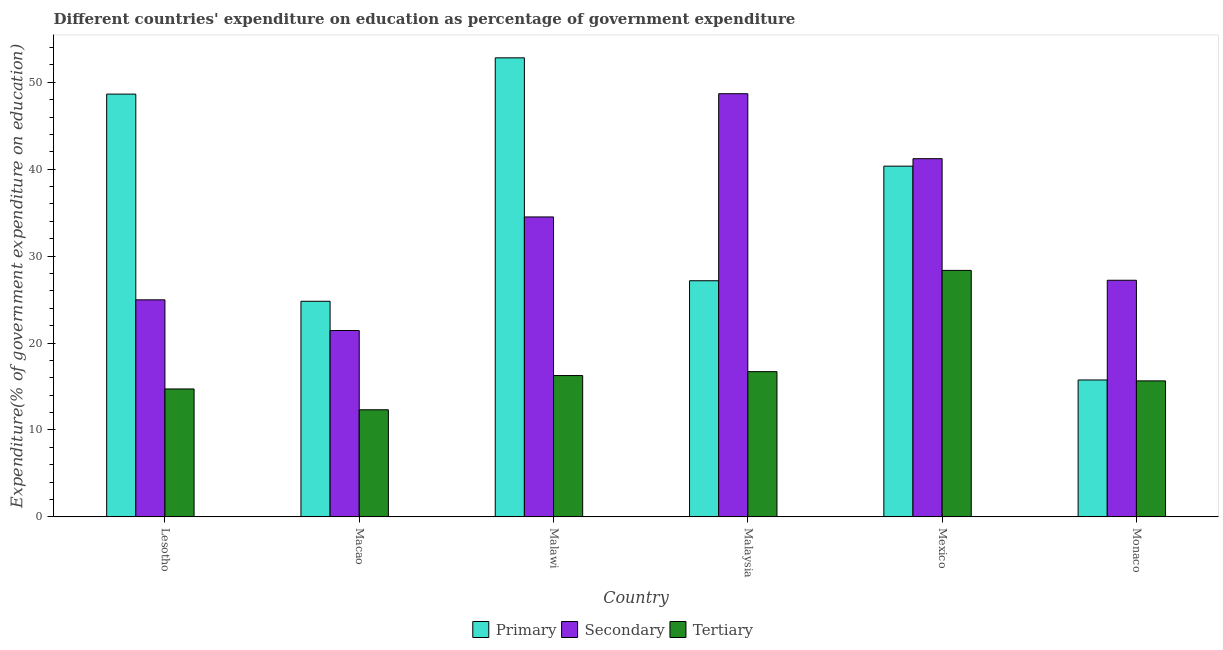How many bars are there on the 1st tick from the left?
Offer a terse response. 3. What is the label of the 5th group of bars from the left?
Provide a short and direct response. Mexico. What is the expenditure on primary education in Monaco?
Make the answer very short. 15.75. Across all countries, what is the maximum expenditure on primary education?
Your answer should be very brief. 52.81. Across all countries, what is the minimum expenditure on secondary education?
Offer a terse response. 21.44. In which country was the expenditure on primary education maximum?
Offer a terse response. Malawi. In which country was the expenditure on secondary education minimum?
Your answer should be very brief. Macao. What is the total expenditure on secondary education in the graph?
Offer a terse response. 198.04. What is the difference between the expenditure on secondary education in Malawi and that in Malaysia?
Your answer should be compact. -14.17. What is the difference between the expenditure on tertiary education in Macao and the expenditure on primary education in Mexico?
Keep it short and to the point. -28.03. What is the average expenditure on secondary education per country?
Offer a terse response. 33.01. What is the difference between the expenditure on primary education and expenditure on tertiary education in Macao?
Your answer should be compact. 12.48. In how many countries, is the expenditure on secondary education greater than 36 %?
Give a very brief answer. 2. What is the ratio of the expenditure on secondary education in Lesotho to that in Malawi?
Give a very brief answer. 0.72. What is the difference between the highest and the second highest expenditure on primary education?
Provide a short and direct response. 4.17. What is the difference between the highest and the lowest expenditure on primary education?
Provide a short and direct response. 37.06. What does the 2nd bar from the left in Lesotho represents?
Your answer should be very brief. Secondary. What does the 1st bar from the right in Mexico represents?
Your answer should be compact. Tertiary. Are all the bars in the graph horizontal?
Keep it short and to the point. No. How many countries are there in the graph?
Provide a short and direct response. 6. Does the graph contain grids?
Offer a terse response. No. How many legend labels are there?
Your answer should be very brief. 3. What is the title of the graph?
Provide a short and direct response. Different countries' expenditure on education as percentage of government expenditure. Does "Wage workers" appear as one of the legend labels in the graph?
Keep it short and to the point. No. What is the label or title of the Y-axis?
Your response must be concise. Expenditure(% of government expenditure on education). What is the Expenditure(% of government expenditure on education) of Primary in Lesotho?
Make the answer very short. 48.64. What is the Expenditure(% of government expenditure on education) in Secondary in Lesotho?
Offer a terse response. 24.97. What is the Expenditure(% of government expenditure on education) in Tertiary in Lesotho?
Offer a very short reply. 14.72. What is the Expenditure(% of government expenditure on education) in Primary in Macao?
Offer a terse response. 24.81. What is the Expenditure(% of government expenditure on education) in Secondary in Macao?
Your answer should be compact. 21.44. What is the Expenditure(% of government expenditure on education) in Tertiary in Macao?
Make the answer very short. 12.32. What is the Expenditure(% of government expenditure on education) of Primary in Malawi?
Your response must be concise. 52.81. What is the Expenditure(% of government expenditure on education) of Secondary in Malawi?
Your answer should be compact. 34.51. What is the Expenditure(% of government expenditure on education) of Tertiary in Malawi?
Provide a short and direct response. 16.26. What is the Expenditure(% of government expenditure on education) in Primary in Malaysia?
Your response must be concise. 27.17. What is the Expenditure(% of government expenditure on education) in Secondary in Malaysia?
Keep it short and to the point. 48.68. What is the Expenditure(% of government expenditure on education) in Tertiary in Malaysia?
Keep it short and to the point. 16.71. What is the Expenditure(% of government expenditure on education) of Primary in Mexico?
Make the answer very short. 40.35. What is the Expenditure(% of government expenditure on education) of Secondary in Mexico?
Your answer should be compact. 41.21. What is the Expenditure(% of government expenditure on education) in Tertiary in Mexico?
Provide a short and direct response. 28.36. What is the Expenditure(% of government expenditure on education) in Primary in Monaco?
Your answer should be compact. 15.75. What is the Expenditure(% of government expenditure on education) in Secondary in Monaco?
Offer a terse response. 27.22. What is the Expenditure(% of government expenditure on education) in Tertiary in Monaco?
Your answer should be compact. 15.65. Across all countries, what is the maximum Expenditure(% of government expenditure on education) of Primary?
Your answer should be very brief. 52.81. Across all countries, what is the maximum Expenditure(% of government expenditure on education) of Secondary?
Make the answer very short. 48.68. Across all countries, what is the maximum Expenditure(% of government expenditure on education) of Tertiary?
Your response must be concise. 28.36. Across all countries, what is the minimum Expenditure(% of government expenditure on education) in Primary?
Ensure brevity in your answer.  15.75. Across all countries, what is the minimum Expenditure(% of government expenditure on education) of Secondary?
Your answer should be compact. 21.44. Across all countries, what is the minimum Expenditure(% of government expenditure on education) in Tertiary?
Provide a short and direct response. 12.32. What is the total Expenditure(% of government expenditure on education) of Primary in the graph?
Ensure brevity in your answer.  209.53. What is the total Expenditure(% of government expenditure on education) of Secondary in the graph?
Ensure brevity in your answer.  198.04. What is the total Expenditure(% of government expenditure on education) in Tertiary in the graph?
Keep it short and to the point. 104.02. What is the difference between the Expenditure(% of government expenditure on education) of Primary in Lesotho and that in Macao?
Your answer should be very brief. 23.83. What is the difference between the Expenditure(% of government expenditure on education) of Secondary in Lesotho and that in Macao?
Keep it short and to the point. 3.53. What is the difference between the Expenditure(% of government expenditure on education) of Tertiary in Lesotho and that in Macao?
Offer a terse response. 2.39. What is the difference between the Expenditure(% of government expenditure on education) in Primary in Lesotho and that in Malawi?
Give a very brief answer. -4.17. What is the difference between the Expenditure(% of government expenditure on education) of Secondary in Lesotho and that in Malawi?
Offer a very short reply. -9.53. What is the difference between the Expenditure(% of government expenditure on education) of Tertiary in Lesotho and that in Malawi?
Provide a succinct answer. -1.54. What is the difference between the Expenditure(% of government expenditure on education) in Primary in Lesotho and that in Malaysia?
Give a very brief answer. 21.47. What is the difference between the Expenditure(% of government expenditure on education) of Secondary in Lesotho and that in Malaysia?
Make the answer very short. -23.71. What is the difference between the Expenditure(% of government expenditure on education) in Tertiary in Lesotho and that in Malaysia?
Your answer should be very brief. -1.99. What is the difference between the Expenditure(% of government expenditure on education) of Primary in Lesotho and that in Mexico?
Your answer should be very brief. 8.29. What is the difference between the Expenditure(% of government expenditure on education) in Secondary in Lesotho and that in Mexico?
Offer a terse response. -16.24. What is the difference between the Expenditure(% of government expenditure on education) in Tertiary in Lesotho and that in Mexico?
Your answer should be very brief. -13.64. What is the difference between the Expenditure(% of government expenditure on education) of Primary in Lesotho and that in Monaco?
Provide a short and direct response. 32.88. What is the difference between the Expenditure(% of government expenditure on education) in Secondary in Lesotho and that in Monaco?
Offer a terse response. -2.25. What is the difference between the Expenditure(% of government expenditure on education) of Tertiary in Lesotho and that in Monaco?
Provide a short and direct response. -0.93. What is the difference between the Expenditure(% of government expenditure on education) of Primary in Macao and that in Malawi?
Provide a succinct answer. -28.01. What is the difference between the Expenditure(% of government expenditure on education) of Secondary in Macao and that in Malawi?
Your answer should be very brief. -13.07. What is the difference between the Expenditure(% of government expenditure on education) of Tertiary in Macao and that in Malawi?
Provide a short and direct response. -3.94. What is the difference between the Expenditure(% of government expenditure on education) of Primary in Macao and that in Malaysia?
Your answer should be very brief. -2.36. What is the difference between the Expenditure(% of government expenditure on education) of Secondary in Macao and that in Malaysia?
Provide a short and direct response. -27.24. What is the difference between the Expenditure(% of government expenditure on education) in Tertiary in Macao and that in Malaysia?
Provide a succinct answer. -4.39. What is the difference between the Expenditure(% of government expenditure on education) of Primary in Macao and that in Mexico?
Your response must be concise. -15.55. What is the difference between the Expenditure(% of government expenditure on education) in Secondary in Macao and that in Mexico?
Give a very brief answer. -19.77. What is the difference between the Expenditure(% of government expenditure on education) in Tertiary in Macao and that in Mexico?
Make the answer very short. -16.03. What is the difference between the Expenditure(% of government expenditure on education) of Primary in Macao and that in Monaco?
Make the answer very short. 9.05. What is the difference between the Expenditure(% of government expenditure on education) of Secondary in Macao and that in Monaco?
Offer a very short reply. -5.78. What is the difference between the Expenditure(% of government expenditure on education) of Tertiary in Macao and that in Monaco?
Your answer should be compact. -3.32. What is the difference between the Expenditure(% of government expenditure on education) of Primary in Malawi and that in Malaysia?
Offer a very short reply. 25.64. What is the difference between the Expenditure(% of government expenditure on education) of Secondary in Malawi and that in Malaysia?
Keep it short and to the point. -14.17. What is the difference between the Expenditure(% of government expenditure on education) of Tertiary in Malawi and that in Malaysia?
Your response must be concise. -0.45. What is the difference between the Expenditure(% of government expenditure on education) in Primary in Malawi and that in Mexico?
Keep it short and to the point. 12.46. What is the difference between the Expenditure(% of government expenditure on education) in Secondary in Malawi and that in Mexico?
Your answer should be very brief. -6.7. What is the difference between the Expenditure(% of government expenditure on education) in Tertiary in Malawi and that in Mexico?
Ensure brevity in your answer.  -12.1. What is the difference between the Expenditure(% of government expenditure on education) in Primary in Malawi and that in Monaco?
Your answer should be compact. 37.06. What is the difference between the Expenditure(% of government expenditure on education) in Secondary in Malawi and that in Monaco?
Your response must be concise. 7.28. What is the difference between the Expenditure(% of government expenditure on education) of Tertiary in Malawi and that in Monaco?
Your answer should be very brief. 0.61. What is the difference between the Expenditure(% of government expenditure on education) of Primary in Malaysia and that in Mexico?
Your response must be concise. -13.18. What is the difference between the Expenditure(% of government expenditure on education) in Secondary in Malaysia and that in Mexico?
Your answer should be compact. 7.47. What is the difference between the Expenditure(% of government expenditure on education) in Tertiary in Malaysia and that in Mexico?
Provide a short and direct response. -11.65. What is the difference between the Expenditure(% of government expenditure on education) of Primary in Malaysia and that in Monaco?
Provide a succinct answer. 11.41. What is the difference between the Expenditure(% of government expenditure on education) in Secondary in Malaysia and that in Monaco?
Make the answer very short. 21.46. What is the difference between the Expenditure(% of government expenditure on education) of Tertiary in Malaysia and that in Monaco?
Your answer should be very brief. 1.06. What is the difference between the Expenditure(% of government expenditure on education) of Primary in Mexico and that in Monaco?
Make the answer very short. 24.6. What is the difference between the Expenditure(% of government expenditure on education) in Secondary in Mexico and that in Monaco?
Your answer should be very brief. 13.99. What is the difference between the Expenditure(% of government expenditure on education) in Tertiary in Mexico and that in Monaco?
Offer a very short reply. 12.71. What is the difference between the Expenditure(% of government expenditure on education) of Primary in Lesotho and the Expenditure(% of government expenditure on education) of Secondary in Macao?
Your answer should be compact. 27.2. What is the difference between the Expenditure(% of government expenditure on education) in Primary in Lesotho and the Expenditure(% of government expenditure on education) in Tertiary in Macao?
Provide a succinct answer. 36.31. What is the difference between the Expenditure(% of government expenditure on education) in Secondary in Lesotho and the Expenditure(% of government expenditure on education) in Tertiary in Macao?
Make the answer very short. 12.65. What is the difference between the Expenditure(% of government expenditure on education) of Primary in Lesotho and the Expenditure(% of government expenditure on education) of Secondary in Malawi?
Offer a very short reply. 14.13. What is the difference between the Expenditure(% of government expenditure on education) of Primary in Lesotho and the Expenditure(% of government expenditure on education) of Tertiary in Malawi?
Provide a succinct answer. 32.38. What is the difference between the Expenditure(% of government expenditure on education) of Secondary in Lesotho and the Expenditure(% of government expenditure on education) of Tertiary in Malawi?
Give a very brief answer. 8.71. What is the difference between the Expenditure(% of government expenditure on education) of Primary in Lesotho and the Expenditure(% of government expenditure on education) of Secondary in Malaysia?
Provide a succinct answer. -0.04. What is the difference between the Expenditure(% of government expenditure on education) of Primary in Lesotho and the Expenditure(% of government expenditure on education) of Tertiary in Malaysia?
Keep it short and to the point. 31.93. What is the difference between the Expenditure(% of government expenditure on education) in Secondary in Lesotho and the Expenditure(% of government expenditure on education) in Tertiary in Malaysia?
Your answer should be compact. 8.26. What is the difference between the Expenditure(% of government expenditure on education) in Primary in Lesotho and the Expenditure(% of government expenditure on education) in Secondary in Mexico?
Offer a very short reply. 7.43. What is the difference between the Expenditure(% of government expenditure on education) of Primary in Lesotho and the Expenditure(% of government expenditure on education) of Tertiary in Mexico?
Offer a very short reply. 20.28. What is the difference between the Expenditure(% of government expenditure on education) in Secondary in Lesotho and the Expenditure(% of government expenditure on education) in Tertiary in Mexico?
Your response must be concise. -3.39. What is the difference between the Expenditure(% of government expenditure on education) in Primary in Lesotho and the Expenditure(% of government expenditure on education) in Secondary in Monaco?
Offer a terse response. 21.41. What is the difference between the Expenditure(% of government expenditure on education) of Primary in Lesotho and the Expenditure(% of government expenditure on education) of Tertiary in Monaco?
Offer a terse response. 32.99. What is the difference between the Expenditure(% of government expenditure on education) in Secondary in Lesotho and the Expenditure(% of government expenditure on education) in Tertiary in Monaco?
Provide a succinct answer. 9.32. What is the difference between the Expenditure(% of government expenditure on education) in Primary in Macao and the Expenditure(% of government expenditure on education) in Secondary in Malawi?
Your response must be concise. -9.7. What is the difference between the Expenditure(% of government expenditure on education) in Primary in Macao and the Expenditure(% of government expenditure on education) in Tertiary in Malawi?
Provide a succinct answer. 8.54. What is the difference between the Expenditure(% of government expenditure on education) of Secondary in Macao and the Expenditure(% of government expenditure on education) of Tertiary in Malawi?
Provide a succinct answer. 5.18. What is the difference between the Expenditure(% of government expenditure on education) of Primary in Macao and the Expenditure(% of government expenditure on education) of Secondary in Malaysia?
Make the answer very short. -23.88. What is the difference between the Expenditure(% of government expenditure on education) of Primary in Macao and the Expenditure(% of government expenditure on education) of Tertiary in Malaysia?
Offer a very short reply. 8.09. What is the difference between the Expenditure(% of government expenditure on education) of Secondary in Macao and the Expenditure(% of government expenditure on education) of Tertiary in Malaysia?
Offer a terse response. 4.73. What is the difference between the Expenditure(% of government expenditure on education) of Primary in Macao and the Expenditure(% of government expenditure on education) of Secondary in Mexico?
Make the answer very short. -16.4. What is the difference between the Expenditure(% of government expenditure on education) in Primary in Macao and the Expenditure(% of government expenditure on education) in Tertiary in Mexico?
Keep it short and to the point. -3.55. What is the difference between the Expenditure(% of government expenditure on education) in Secondary in Macao and the Expenditure(% of government expenditure on education) in Tertiary in Mexico?
Offer a very short reply. -6.92. What is the difference between the Expenditure(% of government expenditure on education) in Primary in Macao and the Expenditure(% of government expenditure on education) in Secondary in Monaco?
Provide a succinct answer. -2.42. What is the difference between the Expenditure(% of government expenditure on education) of Primary in Macao and the Expenditure(% of government expenditure on education) of Tertiary in Monaco?
Give a very brief answer. 9.16. What is the difference between the Expenditure(% of government expenditure on education) of Secondary in Macao and the Expenditure(% of government expenditure on education) of Tertiary in Monaco?
Your answer should be compact. 5.79. What is the difference between the Expenditure(% of government expenditure on education) of Primary in Malawi and the Expenditure(% of government expenditure on education) of Secondary in Malaysia?
Provide a succinct answer. 4.13. What is the difference between the Expenditure(% of government expenditure on education) in Primary in Malawi and the Expenditure(% of government expenditure on education) in Tertiary in Malaysia?
Offer a terse response. 36.1. What is the difference between the Expenditure(% of government expenditure on education) of Secondary in Malawi and the Expenditure(% of government expenditure on education) of Tertiary in Malaysia?
Ensure brevity in your answer.  17.8. What is the difference between the Expenditure(% of government expenditure on education) of Primary in Malawi and the Expenditure(% of government expenditure on education) of Secondary in Mexico?
Ensure brevity in your answer.  11.6. What is the difference between the Expenditure(% of government expenditure on education) in Primary in Malawi and the Expenditure(% of government expenditure on education) in Tertiary in Mexico?
Provide a succinct answer. 24.45. What is the difference between the Expenditure(% of government expenditure on education) in Secondary in Malawi and the Expenditure(% of government expenditure on education) in Tertiary in Mexico?
Provide a short and direct response. 6.15. What is the difference between the Expenditure(% of government expenditure on education) of Primary in Malawi and the Expenditure(% of government expenditure on education) of Secondary in Monaco?
Offer a terse response. 25.59. What is the difference between the Expenditure(% of government expenditure on education) in Primary in Malawi and the Expenditure(% of government expenditure on education) in Tertiary in Monaco?
Make the answer very short. 37.16. What is the difference between the Expenditure(% of government expenditure on education) in Secondary in Malawi and the Expenditure(% of government expenditure on education) in Tertiary in Monaco?
Ensure brevity in your answer.  18.86. What is the difference between the Expenditure(% of government expenditure on education) of Primary in Malaysia and the Expenditure(% of government expenditure on education) of Secondary in Mexico?
Give a very brief answer. -14.04. What is the difference between the Expenditure(% of government expenditure on education) of Primary in Malaysia and the Expenditure(% of government expenditure on education) of Tertiary in Mexico?
Your response must be concise. -1.19. What is the difference between the Expenditure(% of government expenditure on education) of Secondary in Malaysia and the Expenditure(% of government expenditure on education) of Tertiary in Mexico?
Provide a succinct answer. 20.32. What is the difference between the Expenditure(% of government expenditure on education) in Primary in Malaysia and the Expenditure(% of government expenditure on education) in Secondary in Monaco?
Ensure brevity in your answer.  -0.06. What is the difference between the Expenditure(% of government expenditure on education) in Primary in Malaysia and the Expenditure(% of government expenditure on education) in Tertiary in Monaco?
Your answer should be compact. 11.52. What is the difference between the Expenditure(% of government expenditure on education) in Secondary in Malaysia and the Expenditure(% of government expenditure on education) in Tertiary in Monaco?
Provide a short and direct response. 33.03. What is the difference between the Expenditure(% of government expenditure on education) in Primary in Mexico and the Expenditure(% of government expenditure on education) in Secondary in Monaco?
Provide a succinct answer. 13.13. What is the difference between the Expenditure(% of government expenditure on education) in Primary in Mexico and the Expenditure(% of government expenditure on education) in Tertiary in Monaco?
Keep it short and to the point. 24.7. What is the difference between the Expenditure(% of government expenditure on education) of Secondary in Mexico and the Expenditure(% of government expenditure on education) of Tertiary in Monaco?
Offer a terse response. 25.56. What is the average Expenditure(% of government expenditure on education) of Primary per country?
Offer a terse response. 34.92. What is the average Expenditure(% of government expenditure on education) of Secondary per country?
Give a very brief answer. 33.01. What is the average Expenditure(% of government expenditure on education) of Tertiary per country?
Provide a succinct answer. 17.34. What is the difference between the Expenditure(% of government expenditure on education) in Primary and Expenditure(% of government expenditure on education) in Secondary in Lesotho?
Your answer should be compact. 23.67. What is the difference between the Expenditure(% of government expenditure on education) of Primary and Expenditure(% of government expenditure on education) of Tertiary in Lesotho?
Give a very brief answer. 33.92. What is the difference between the Expenditure(% of government expenditure on education) of Secondary and Expenditure(% of government expenditure on education) of Tertiary in Lesotho?
Make the answer very short. 10.25. What is the difference between the Expenditure(% of government expenditure on education) of Primary and Expenditure(% of government expenditure on education) of Secondary in Macao?
Keep it short and to the point. 3.37. What is the difference between the Expenditure(% of government expenditure on education) of Primary and Expenditure(% of government expenditure on education) of Tertiary in Macao?
Provide a succinct answer. 12.48. What is the difference between the Expenditure(% of government expenditure on education) of Secondary and Expenditure(% of government expenditure on education) of Tertiary in Macao?
Make the answer very short. 9.12. What is the difference between the Expenditure(% of government expenditure on education) of Primary and Expenditure(% of government expenditure on education) of Secondary in Malawi?
Your response must be concise. 18.3. What is the difference between the Expenditure(% of government expenditure on education) of Primary and Expenditure(% of government expenditure on education) of Tertiary in Malawi?
Offer a very short reply. 36.55. What is the difference between the Expenditure(% of government expenditure on education) of Secondary and Expenditure(% of government expenditure on education) of Tertiary in Malawi?
Keep it short and to the point. 18.25. What is the difference between the Expenditure(% of government expenditure on education) of Primary and Expenditure(% of government expenditure on education) of Secondary in Malaysia?
Your answer should be compact. -21.51. What is the difference between the Expenditure(% of government expenditure on education) in Primary and Expenditure(% of government expenditure on education) in Tertiary in Malaysia?
Provide a succinct answer. 10.46. What is the difference between the Expenditure(% of government expenditure on education) of Secondary and Expenditure(% of government expenditure on education) of Tertiary in Malaysia?
Provide a short and direct response. 31.97. What is the difference between the Expenditure(% of government expenditure on education) of Primary and Expenditure(% of government expenditure on education) of Secondary in Mexico?
Your response must be concise. -0.86. What is the difference between the Expenditure(% of government expenditure on education) in Primary and Expenditure(% of government expenditure on education) in Tertiary in Mexico?
Provide a succinct answer. 11.99. What is the difference between the Expenditure(% of government expenditure on education) in Secondary and Expenditure(% of government expenditure on education) in Tertiary in Mexico?
Offer a very short reply. 12.85. What is the difference between the Expenditure(% of government expenditure on education) in Primary and Expenditure(% of government expenditure on education) in Secondary in Monaco?
Give a very brief answer. -11.47. What is the difference between the Expenditure(% of government expenditure on education) of Primary and Expenditure(% of government expenditure on education) of Tertiary in Monaco?
Provide a short and direct response. 0.1. What is the difference between the Expenditure(% of government expenditure on education) of Secondary and Expenditure(% of government expenditure on education) of Tertiary in Monaco?
Offer a terse response. 11.58. What is the ratio of the Expenditure(% of government expenditure on education) of Primary in Lesotho to that in Macao?
Provide a succinct answer. 1.96. What is the ratio of the Expenditure(% of government expenditure on education) in Secondary in Lesotho to that in Macao?
Your answer should be compact. 1.16. What is the ratio of the Expenditure(% of government expenditure on education) of Tertiary in Lesotho to that in Macao?
Offer a very short reply. 1.19. What is the ratio of the Expenditure(% of government expenditure on education) of Primary in Lesotho to that in Malawi?
Ensure brevity in your answer.  0.92. What is the ratio of the Expenditure(% of government expenditure on education) of Secondary in Lesotho to that in Malawi?
Make the answer very short. 0.72. What is the ratio of the Expenditure(% of government expenditure on education) in Tertiary in Lesotho to that in Malawi?
Your answer should be very brief. 0.91. What is the ratio of the Expenditure(% of government expenditure on education) of Primary in Lesotho to that in Malaysia?
Your response must be concise. 1.79. What is the ratio of the Expenditure(% of government expenditure on education) in Secondary in Lesotho to that in Malaysia?
Your response must be concise. 0.51. What is the ratio of the Expenditure(% of government expenditure on education) of Tertiary in Lesotho to that in Malaysia?
Make the answer very short. 0.88. What is the ratio of the Expenditure(% of government expenditure on education) in Primary in Lesotho to that in Mexico?
Provide a succinct answer. 1.21. What is the ratio of the Expenditure(% of government expenditure on education) of Secondary in Lesotho to that in Mexico?
Offer a terse response. 0.61. What is the ratio of the Expenditure(% of government expenditure on education) in Tertiary in Lesotho to that in Mexico?
Your response must be concise. 0.52. What is the ratio of the Expenditure(% of government expenditure on education) in Primary in Lesotho to that in Monaco?
Your answer should be compact. 3.09. What is the ratio of the Expenditure(% of government expenditure on education) in Secondary in Lesotho to that in Monaco?
Provide a succinct answer. 0.92. What is the ratio of the Expenditure(% of government expenditure on education) in Tertiary in Lesotho to that in Monaco?
Keep it short and to the point. 0.94. What is the ratio of the Expenditure(% of government expenditure on education) of Primary in Macao to that in Malawi?
Make the answer very short. 0.47. What is the ratio of the Expenditure(% of government expenditure on education) in Secondary in Macao to that in Malawi?
Provide a short and direct response. 0.62. What is the ratio of the Expenditure(% of government expenditure on education) in Tertiary in Macao to that in Malawi?
Offer a very short reply. 0.76. What is the ratio of the Expenditure(% of government expenditure on education) of Primary in Macao to that in Malaysia?
Your response must be concise. 0.91. What is the ratio of the Expenditure(% of government expenditure on education) of Secondary in Macao to that in Malaysia?
Your response must be concise. 0.44. What is the ratio of the Expenditure(% of government expenditure on education) in Tertiary in Macao to that in Malaysia?
Provide a succinct answer. 0.74. What is the ratio of the Expenditure(% of government expenditure on education) in Primary in Macao to that in Mexico?
Provide a succinct answer. 0.61. What is the ratio of the Expenditure(% of government expenditure on education) in Secondary in Macao to that in Mexico?
Your answer should be very brief. 0.52. What is the ratio of the Expenditure(% of government expenditure on education) in Tertiary in Macao to that in Mexico?
Your answer should be very brief. 0.43. What is the ratio of the Expenditure(% of government expenditure on education) of Primary in Macao to that in Monaco?
Your answer should be compact. 1.57. What is the ratio of the Expenditure(% of government expenditure on education) in Secondary in Macao to that in Monaco?
Provide a short and direct response. 0.79. What is the ratio of the Expenditure(% of government expenditure on education) in Tertiary in Macao to that in Monaco?
Keep it short and to the point. 0.79. What is the ratio of the Expenditure(% of government expenditure on education) in Primary in Malawi to that in Malaysia?
Make the answer very short. 1.94. What is the ratio of the Expenditure(% of government expenditure on education) of Secondary in Malawi to that in Malaysia?
Your answer should be very brief. 0.71. What is the ratio of the Expenditure(% of government expenditure on education) of Tertiary in Malawi to that in Malaysia?
Keep it short and to the point. 0.97. What is the ratio of the Expenditure(% of government expenditure on education) in Primary in Malawi to that in Mexico?
Your response must be concise. 1.31. What is the ratio of the Expenditure(% of government expenditure on education) of Secondary in Malawi to that in Mexico?
Your response must be concise. 0.84. What is the ratio of the Expenditure(% of government expenditure on education) of Tertiary in Malawi to that in Mexico?
Keep it short and to the point. 0.57. What is the ratio of the Expenditure(% of government expenditure on education) in Primary in Malawi to that in Monaco?
Offer a terse response. 3.35. What is the ratio of the Expenditure(% of government expenditure on education) of Secondary in Malawi to that in Monaco?
Provide a succinct answer. 1.27. What is the ratio of the Expenditure(% of government expenditure on education) of Tertiary in Malawi to that in Monaco?
Provide a short and direct response. 1.04. What is the ratio of the Expenditure(% of government expenditure on education) of Primary in Malaysia to that in Mexico?
Ensure brevity in your answer.  0.67. What is the ratio of the Expenditure(% of government expenditure on education) of Secondary in Malaysia to that in Mexico?
Provide a succinct answer. 1.18. What is the ratio of the Expenditure(% of government expenditure on education) of Tertiary in Malaysia to that in Mexico?
Your response must be concise. 0.59. What is the ratio of the Expenditure(% of government expenditure on education) in Primary in Malaysia to that in Monaco?
Your answer should be compact. 1.72. What is the ratio of the Expenditure(% of government expenditure on education) in Secondary in Malaysia to that in Monaco?
Your answer should be very brief. 1.79. What is the ratio of the Expenditure(% of government expenditure on education) in Tertiary in Malaysia to that in Monaco?
Your response must be concise. 1.07. What is the ratio of the Expenditure(% of government expenditure on education) in Primary in Mexico to that in Monaco?
Provide a short and direct response. 2.56. What is the ratio of the Expenditure(% of government expenditure on education) in Secondary in Mexico to that in Monaco?
Your response must be concise. 1.51. What is the ratio of the Expenditure(% of government expenditure on education) of Tertiary in Mexico to that in Monaco?
Provide a succinct answer. 1.81. What is the difference between the highest and the second highest Expenditure(% of government expenditure on education) of Primary?
Provide a succinct answer. 4.17. What is the difference between the highest and the second highest Expenditure(% of government expenditure on education) of Secondary?
Give a very brief answer. 7.47. What is the difference between the highest and the second highest Expenditure(% of government expenditure on education) in Tertiary?
Provide a short and direct response. 11.65. What is the difference between the highest and the lowest Expenditure(% of government expenditure on education) of Primary?
Make the answer very short. 37.06. What is the difference between the highest and the lowest Expenditure(% of government expenditure on education) of Secondary?
Give a very brief answer. 27.24. What is the difference between the highest and the lowest Expenditure(% of government expenditure on education) of Tertiary?
Offer a terse response. 16.03. 